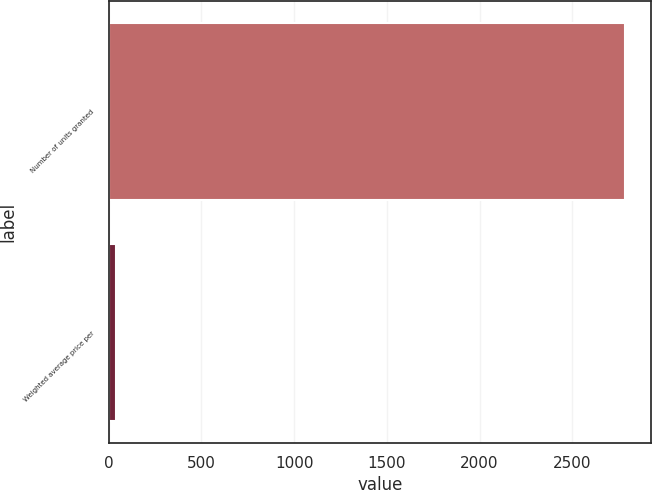<chart> <loc_0><loc_0><loc_500><loc_500><bar_chart><fcel>Number of units granted<fcel>Weighted average price per<nl><fcel>2785.7<fcel>37.29<nl></chart> 